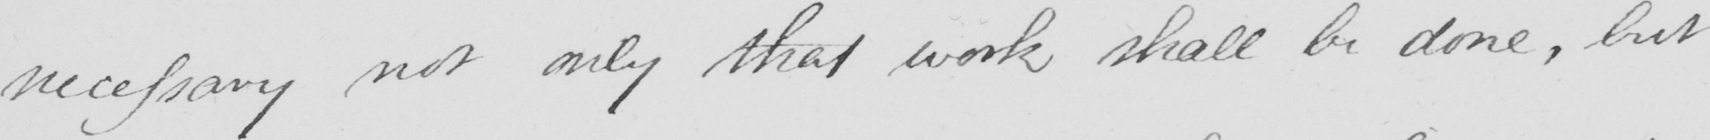Can you read and transcribe this handwriting? necessary not only that work shall be done , but 